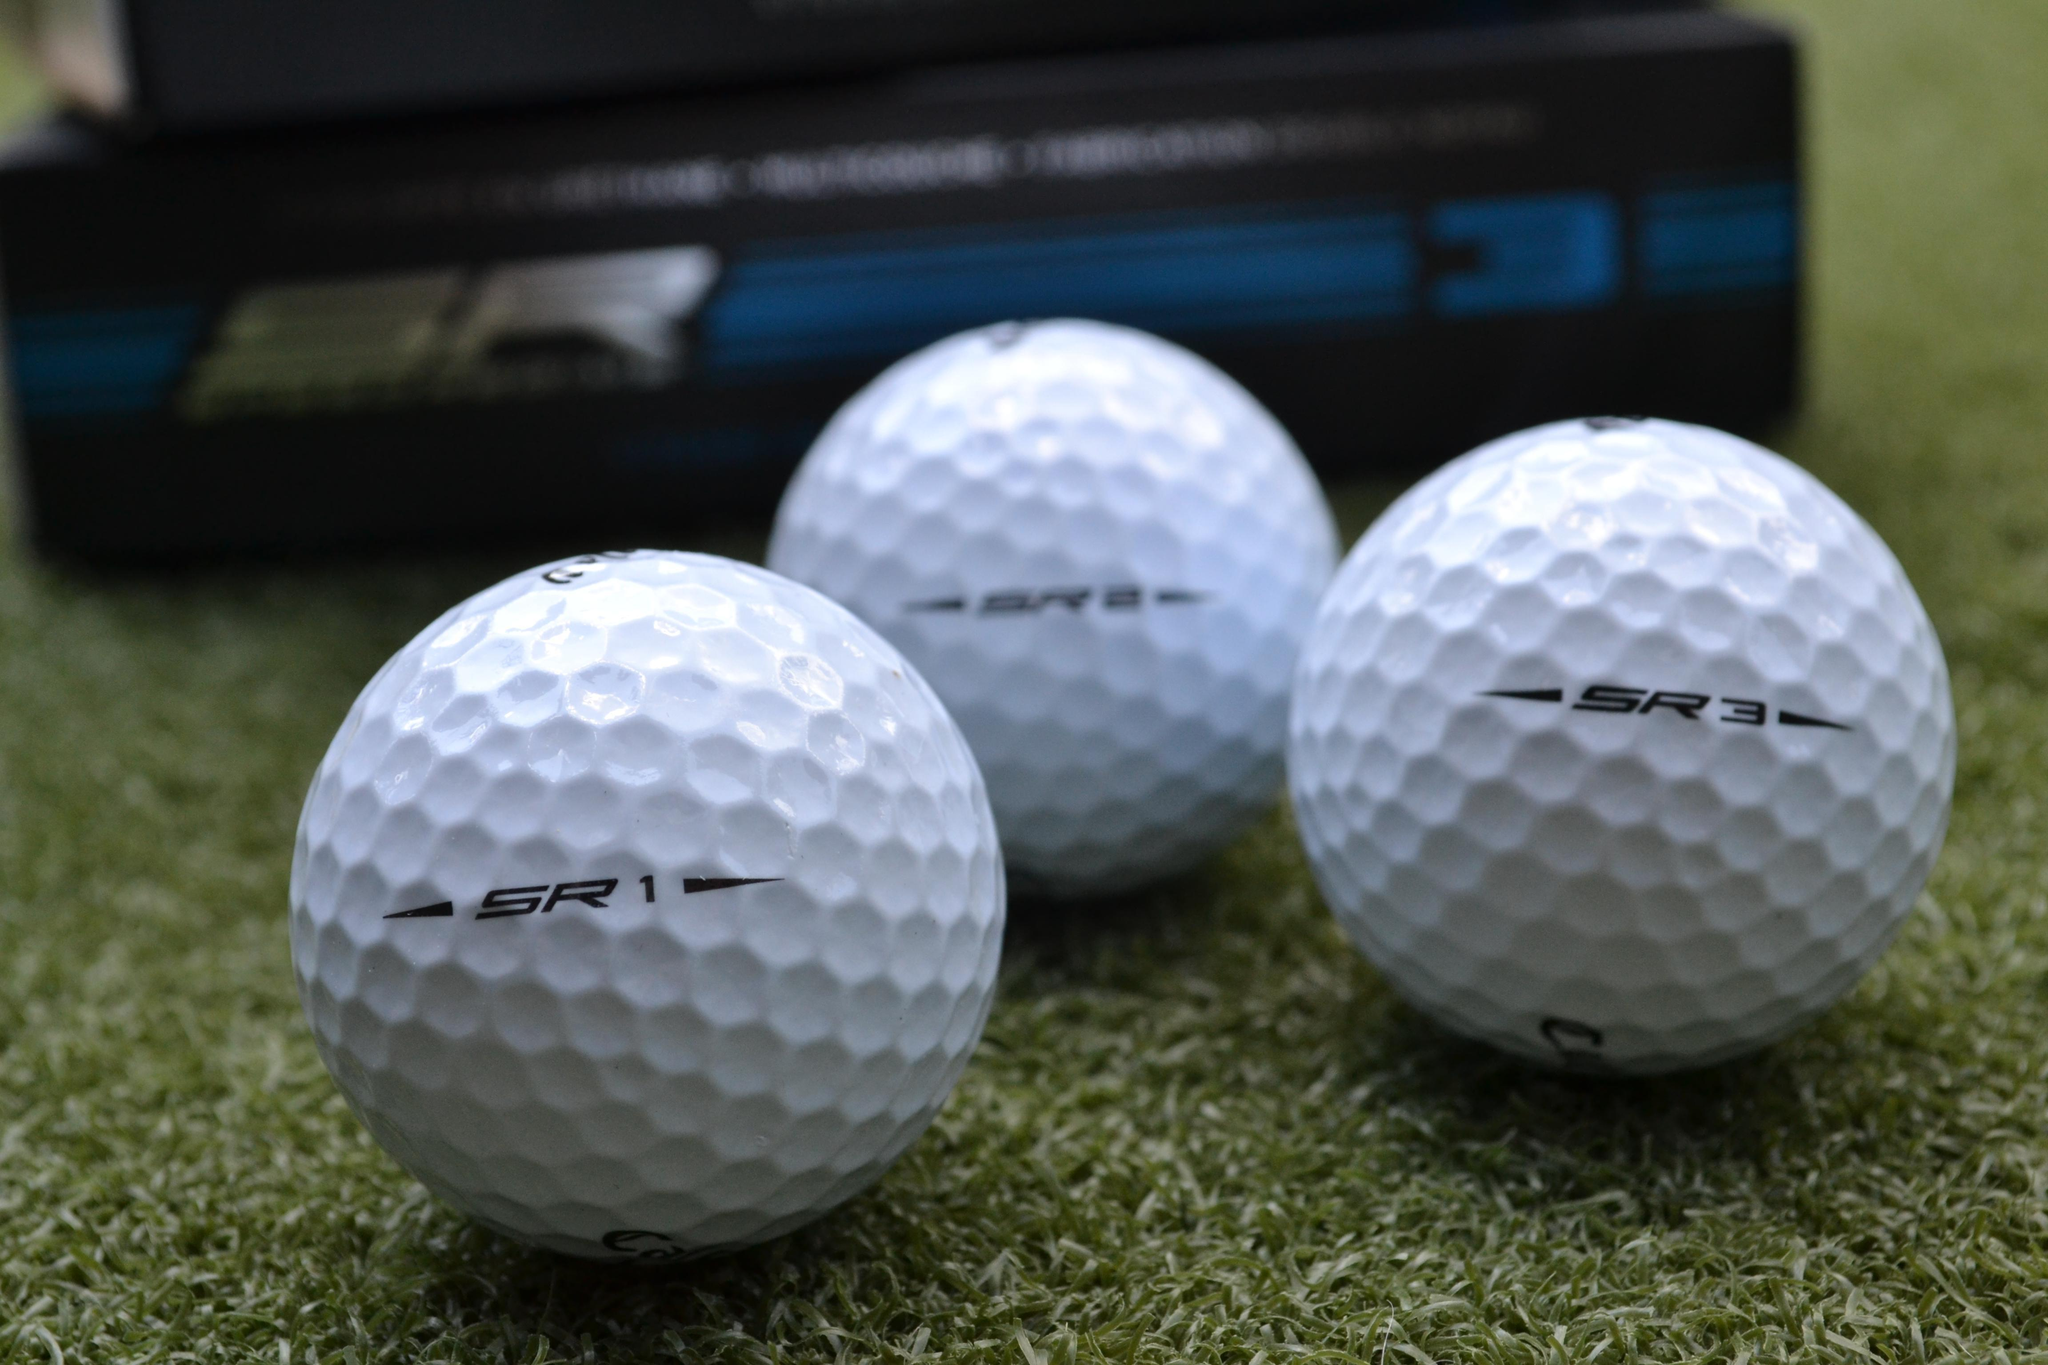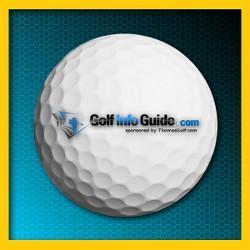The first image is the image on the left, the second image is the image on the right. Examine the images to the left and right. Is the description "The left image features three white golf balls in a straight row under a silver box with gold trim." accurate? Answer yes or no. No. The first image is the image on the left, the second image is the image on the right. Examine the images to the left and right. Is the description "There are three golf balls in the left image and one in the right." accurate? Answer yes or no. Yes. 